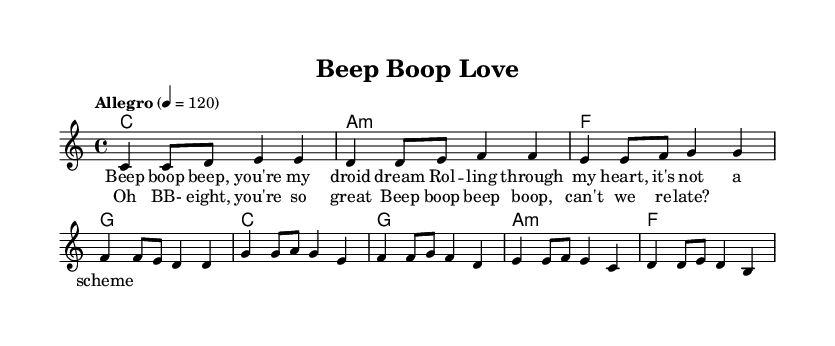What is the time signature of this music? The time signature is shown as a notation at the beginning of the score, indicated by "4/4". This means there are four beats in each measure, and the quarter note gets one beat.
Answer: 4/4 What is the tempo marking of the piece? The tempo marking appears right before the melody section of the score and is indicated with the word "Allegro" followed by a metronome marking of 120. This indicates a fast tempo for the piece.
Answer: Allegro 4 = 120 How many measures are in the verse? By counting the bars (measure lines) in the verse section of the sheet music, we see there are 4 measures that make up the verse.
Answer: 4 What chord comes after the second line of the verse? In the harmonies section, we analyze the chord progression during the verse. The second line of the verse corresponds to the "G" chord.
Answer: G What lyrical theme is represented in the chorus? The lyrics in the chorus describe admiration for BB-8 and use playful, light-hearted language that represents a theme of love and connection. This is typical of upbeat pop music.
Answer: Love and connection Which section has a different rhythmic pattern, verse or chorus? Upon examining both sections, the chorus has a distinctive rhythmic pattern with a significant leap from the previous melodies in the verse, creating a more engaging and repetitive effect typical of pop music.
Answer: Chorus What is the key signature of this music? The key signature is determined by the presence of sharps or flats at the beginning of the music. In this sheet, there are no sharps or flats, indicating that the key is C major.
Answer: C major 